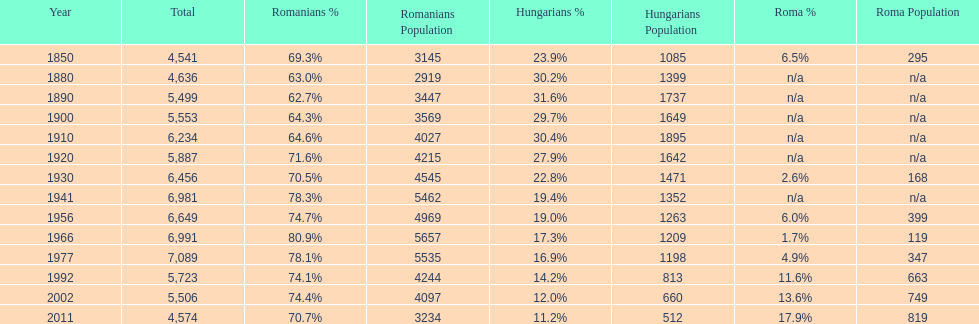What is the number of hungarians in 1850? 23.9%. 